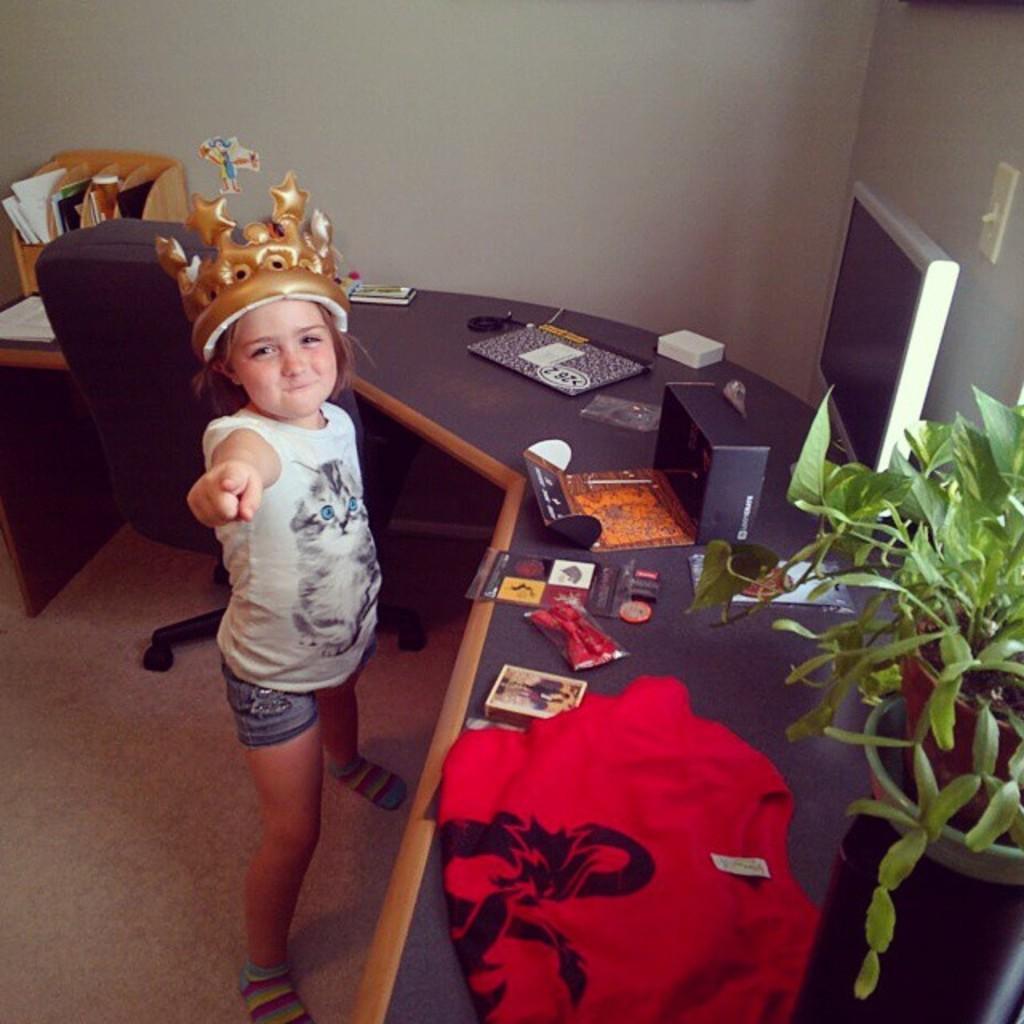Can you describe this image briefly? On the middle of an image there is a work desk on this desk there is a cloth. Beside of it there is a plant and here it is the left side of an image there is a girl standing wearing short and crown 